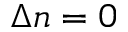Convert formula to latex. <formula><loc_0><loc_0><loc_500><loc_500>\Delta n = 0</formula> 